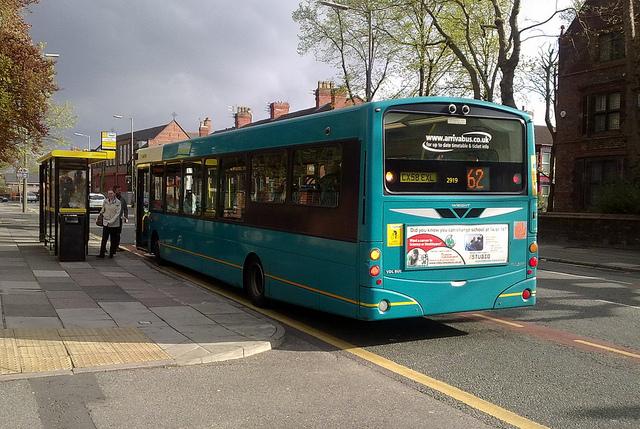What color is the bus?
Be succinct. Blue. Is the door to the bus open?
Be succinct. Yes. How many levels does this bus have?
Keep it brief. 1. Are the trees visible?
Short answer required. Yes. What is the color on top of the bus stop?
Give a very brief answer. Yellow. 